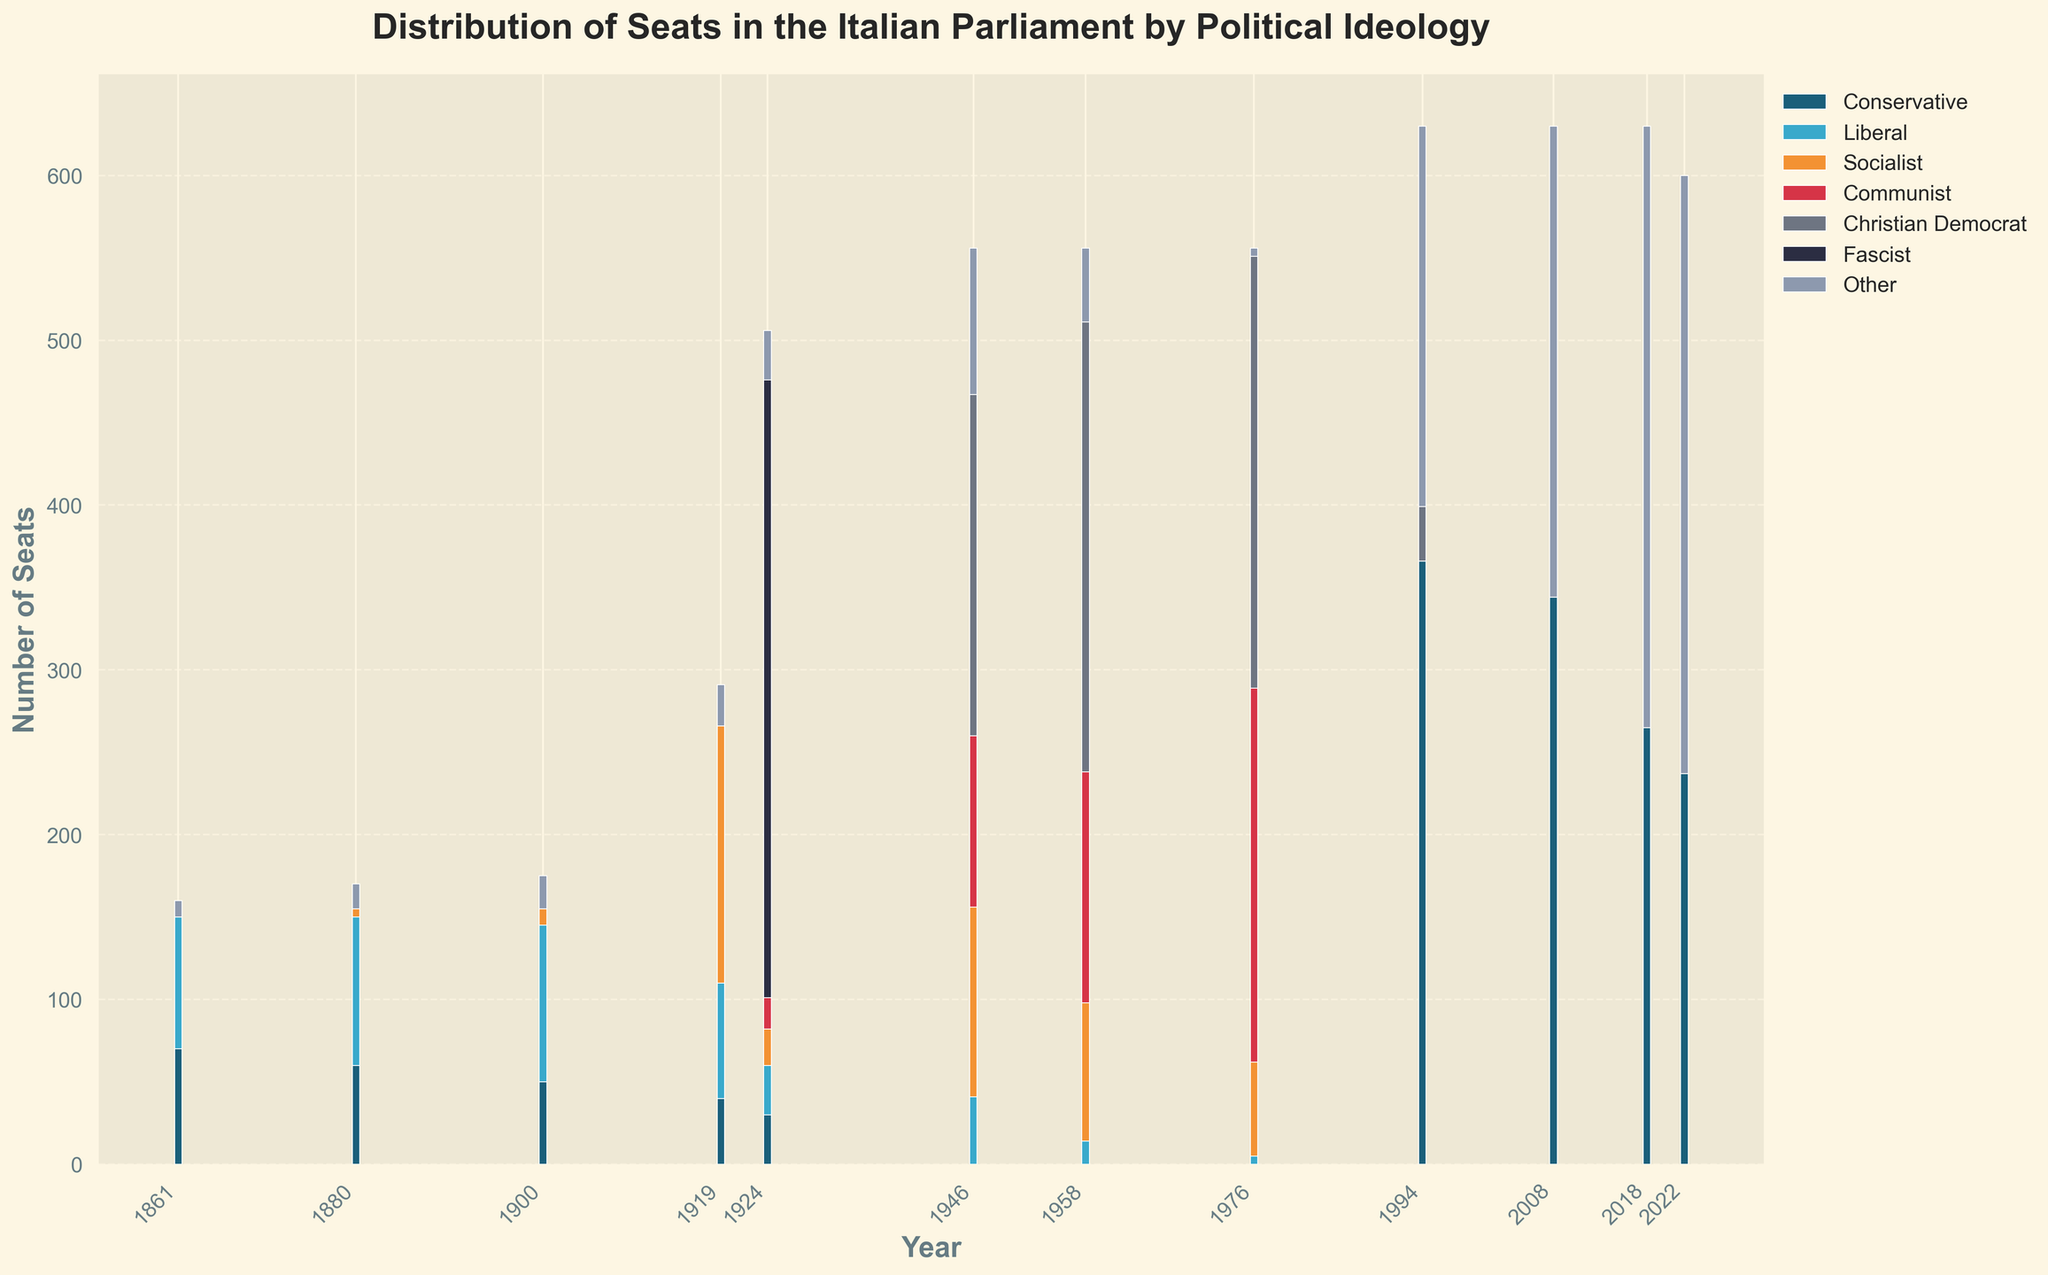How many seats are held by Conservatives and Christian Democrats combined in 1958? In 1958, the number of seats held by Conservatives is 0, and the number of seats held by Christian Democrats is 273. Adding these together: 0 + 273 = 273
Answer: 273 In which year did the Fascists have the highest number of seats? From the data, the Fascists had seats only in 1924, and they held 375 seats. Therefore, 1924 is the year with the highest number of seats for Fascists.
Answer: 1924 Which political ideology had the most seats in 2022? From the data for 2022, Conservatives had 237 seats, and 'Other' had 363 seats. Comparing both, 'Other' has more seats at 363.
Answer: Other In what year did Socialists have more seats than Conservatives? Comparing the data across years, only in 1919, 1946, and 1958 did Socialists have more seats than Conservatives. For instance, in 1919 Socialists had 156 seats while Conservatives had 40.
Answer: 1919, 1946, 1958 How did the number of seats held by Liberals change from 1880 to 2008? In 1880, Liberals held 90 seats, and in 2008, they held 0 seats. The change can be found by subtracting the seats in 2008 from 1880: 90 - 0 = 90.
Answer: -90 How many years have there been no Communist party seats in Parliament? Checking the data, no Communist seats appear in 1861, 1880, 1900, 2018, and 2022. Counting these years gives us a total of 5 years.
Answer: 5 In which year did the Communists gain the largest number of seats compared to the previous recorded year? Analyzing the changes, from 1919 (0 seats) to 1924 (19 seats) the communists increased by 19 seats. From 1946, they gained 104 seats (higher than from 1919 to 1924). Comparing these, the largest gain happened from 1946 (104 seats) to 1958 (140 seats), an increase of 36.
Answer: 1946 to 1958 In which years did 'Other' hold more than 20 seats but less than 100 seats? 'Other' had seats within this range in 1861 (10), 1880 (15), 1900 (20), 1919 (25), 1946 (89), 1958 (45), while in other years, it either exceeds or does not reach this range.
Answer: 1946, 1958 